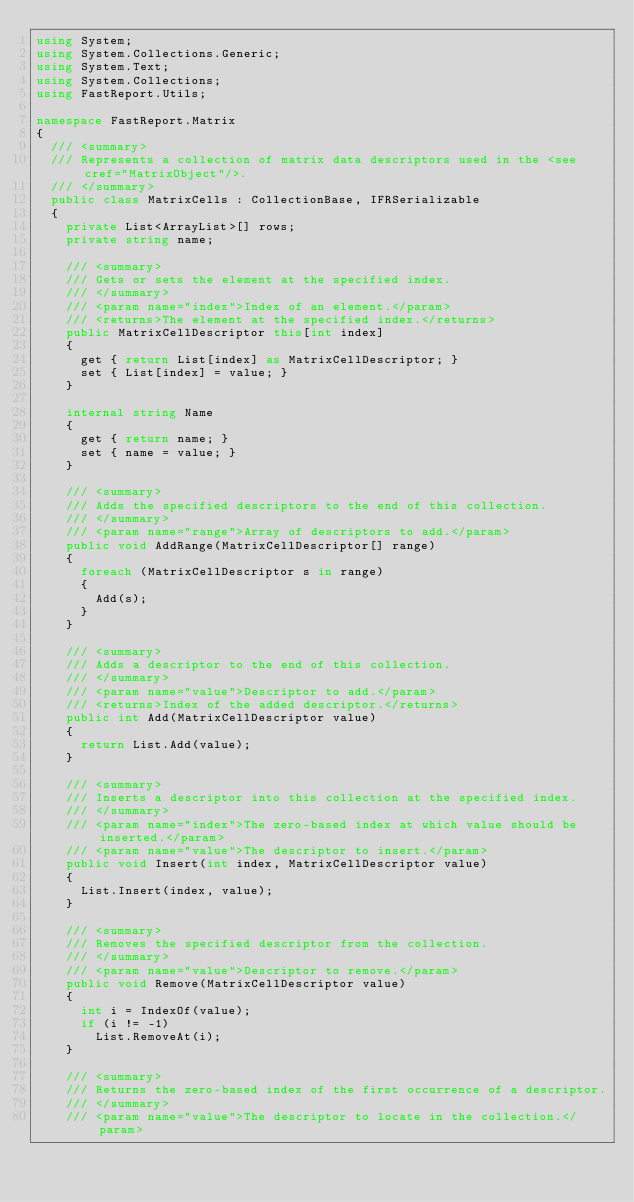Convert code to text. <code><loc_0><loc_0><loc_500><loc_500><_C#_>using System;
using System.Collections.Generic;
using System.Text;
using System.Collections;
using FastReport.Utils;

namespace FastReport.Matrix
{
  /// <summary>
  /// Represents a collection of matrix data descriptors used in the <see cref="MatrixObject"/>.
  /// </summary>
  public class MatrixCells : CollectionBase, IFRSerializable
  {
    private List<ArrayList>[] rows;
    private string name;

    /// <summary>
    /// Gets or sets the element at the specified index.
    /// </summary>
    /// <param name="index">Index of an element.</param>
    /// <returns>The element at the specified index.</returns>
    public MatrixCellDescriptor this[int index]
    {
      get { return List[index] as MatrixCellDescriptor; }
      set { List[index] = value; }
    }

    internal string Name
    {
      get { return name; }
      set { name = value; }
    }

    /// <summary>
    /// Adds the specified descriptors to the end of this collection.
    /// </summary>
    /// <param name="range">Array of descriptors to add.</param>
    public void AddRange(MatrixCellDescriptor[] range)
    {
      foreach (MatrixCellDescriptor s in range)
      {
        Add(s);
      }
    }

    /// <summary>
    /// Adds a descriptor to the end of this collection.
    /// </summary>
    /// <param name="value">Descriptor to add.</param>
    /// <returns>Index of the added descriptor.</returns>
    public int Add(MatrixCellDescriptor value)
    {
      return List.Add(value);
    }

    /// <summary>
    /// Inserts a descriptor into this collection at the specified index.
    /// </summary>
    /// <param name="index">The zero-based index at which value should be inserted.</param>
    /// <param name="value">The descriptor to insert.</param>
    public void Insert(int index, MatrixCellDescriptor value)
    {
      List.Insert(index, value);
    }

    /// <summary>
    /// Removes the specified descriptor from the collection.
    /// </summary>
    /// <param name="value">Descriptor to remove.</param>
    public void Remove(MatrixCellDescriptor value)
    {
      int i = IndexOf(value);
      if (i != -1)
        List.RemoveAt(i);
    }

    /// <summary>
    /// Returns the zero-based index of the first occurrence of a descriptor.
    /// </summary>
    /// <param name="value">The descriptor to locate in the collection.</param></code> 